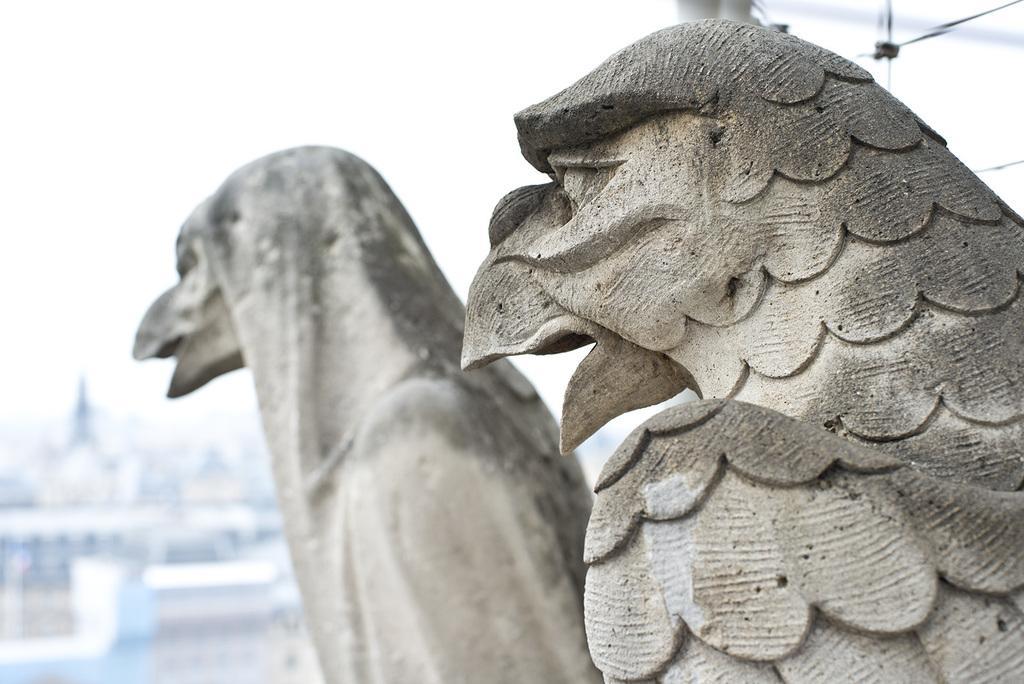Describe this image in one or two sentences. In the center of the image there is a statue. In the background we can see buildings and sky. 